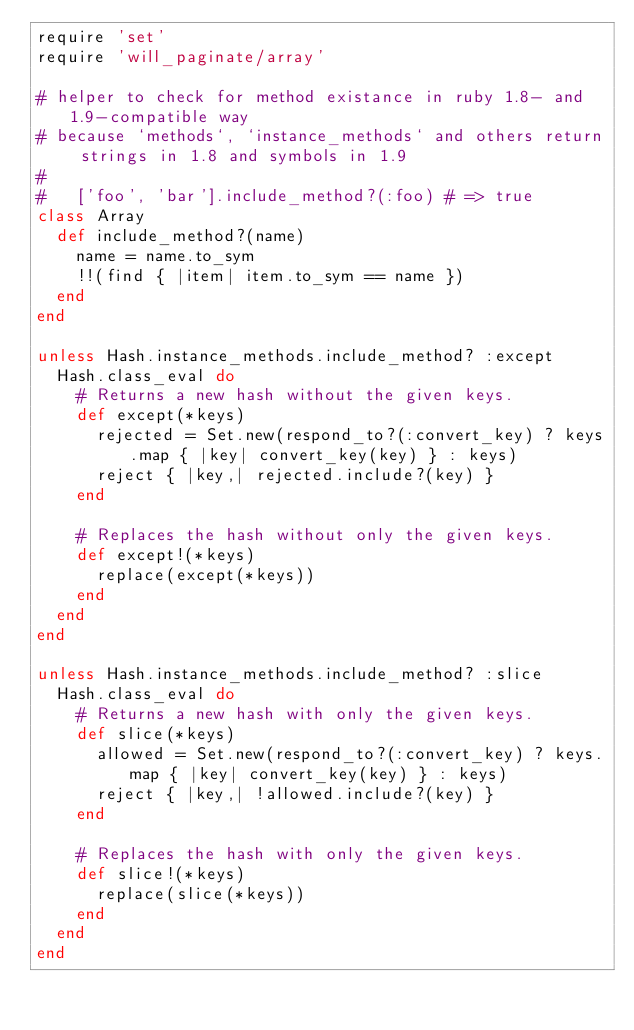Convert code to text. <code><loc_0><loc_0><loc_500><loc_500><_Ruby_>require 'set'
require 'will_paginate/array'

# helper to check for method existance in ruby 1.8- and 1.9-compatible way
# because `methods`, `instance_methods` and others return strings in 1.8 and symbols in 1.9
#
#   ['foo', 'bar'].include_method?(:foo) # => true
class Array
  def include_method?(name)
    name = name.to_sym
    !!(find { |item| item.to_sym == name })
  end
end

unless Hash.instance_methods.include_method? :except
  Hash.class_eval do
    # Returns a new hash without the given keys.
    def except(*keys)
      rejected = Set.new(respond_to?(:convert_key) ? keys.map { |key| convert_key(key) } : keys)
      reject { |key,| rejected.include?(key) }
    end
 
    # Replaces the hash without only the given keys.
    def except!(*keys)
      replace(except(*keys))
    end
  end
end

unless Hash.instance_methods.include_method? :slice
  Hash.class_eval do
    # Returns a new hash with only the given keys.
    def slice(*keys)
      allowed = Set.new(respond_to?(:convert_key) ? keys.map { |key| convert_key(key) } : keys)
      reject { |key,| !allowed.include?(key) }
    end

    # Replaces the hash with only the given keys.
    def slice!(*keys)
      replace(slice(*keys))
    end
  end
end
</code> 